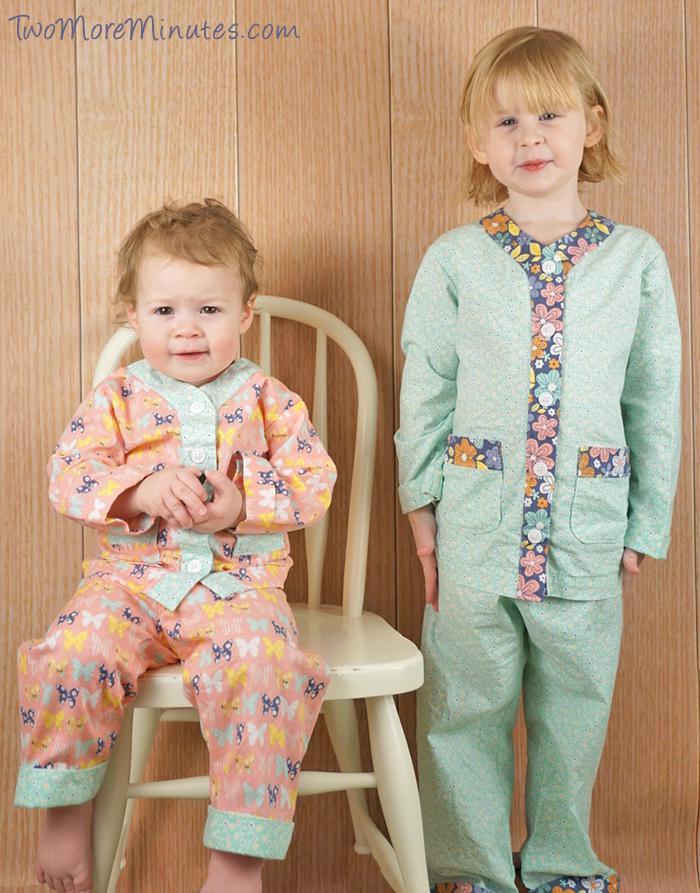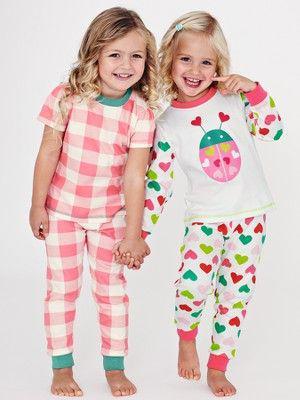The first image is the image on the left, the second image is the image on the right. Given the left and right images, does the statement "There are three children" hold true? Answer yes or no. No. The first image is the image on the left, the second image is the image on the right. Evaluate the accuracy of this statement regarding the images: "There is atleast one photo with two girls holding hands". Is it true? Answer yes or no. Yes. 